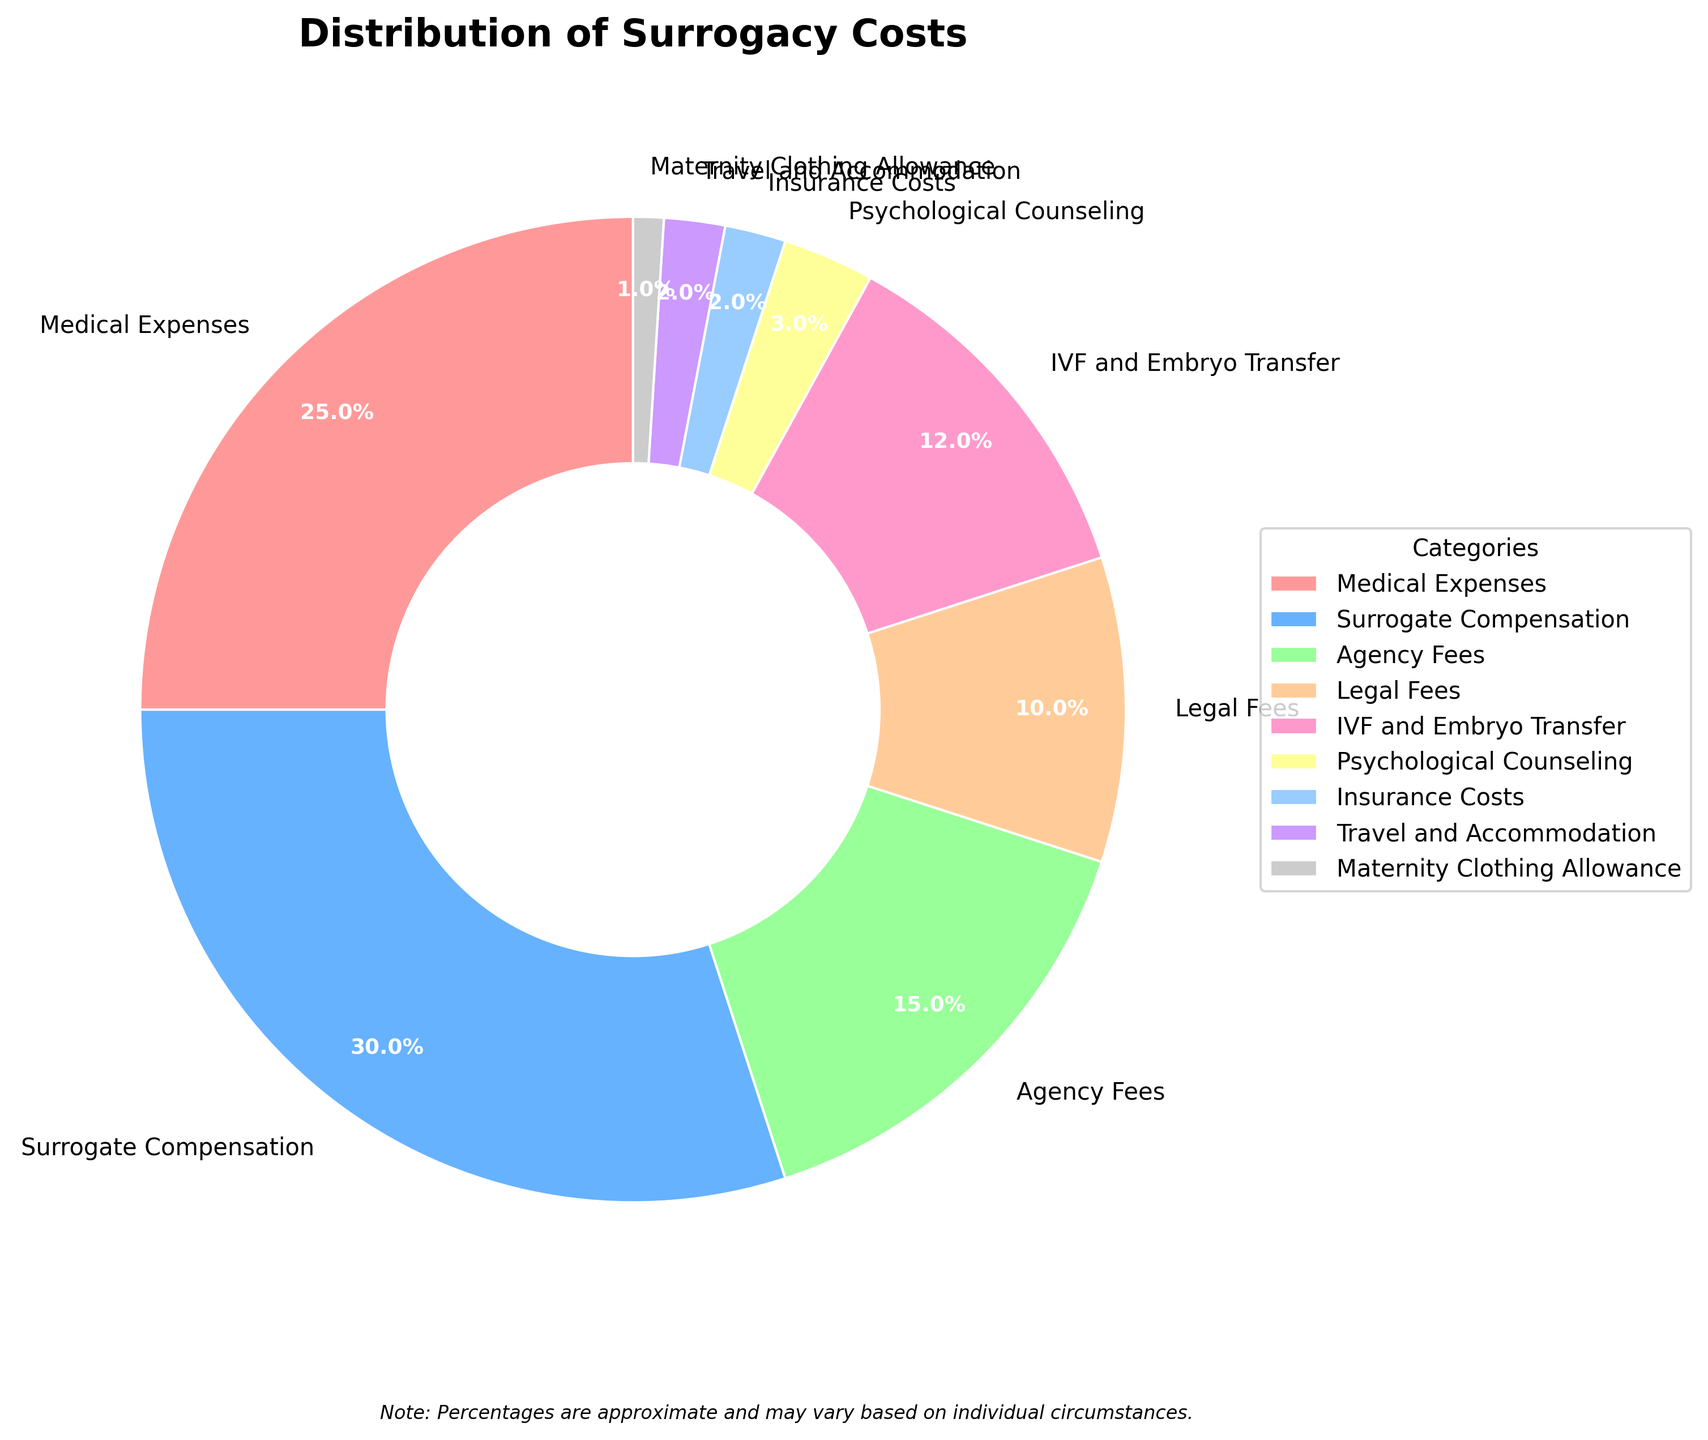What's the largest cost category for surrogacy? The largest slice in the pie chart represents Surrogate Compensation, which is 30%.
Answer: Surrogate Compensation What is the difference in percentage between Medical Expenses and Agency Fees? Medical Expenses represent 25%, while Agency Fees are 15%. The difference is 25% - 15% = 10%.
Answer: 10% What is the total percentage of costs represented by the combination of Psychological Counseling, Insurance Costs, Travel and Accommodation, and Maternity Clothing Allowance? Psychological Counseling is 3%, Insurance Costs are 2%, Travel and Accommodation is 2%, and Maternity Clothing Allowance is 1%. Summing these up: 3% + 2% + 2% + 1% = 8%.
Answer: 8% Which category costs more: IVF and Embryo Transfer or Legal Fees? IVF and Embryo Transfer account for 12%, while Legal Fees are 10%. IVF and Embryo Transfer is higher.
Answer: IVF and Embryo Transfer How much more does Surrogate Compensation cost compared to Legal Fees? Surrogate Compensation is 30%, while Legal Fees are 10%. The difference is 30% - 10% = 20%.
Answer: 20% Which cost categories collectively account for at least half of the surrogacy costs? Surrogate Compensation (30%), Medical Expenses (25%). Summing these gives 30% + 25% = 55%, which is more than half.
Answer: Surrogate Compensation and Medical Expenses What percentage of the costs are associated with both Medical Expenses and IVF and Embryo Transfer? Medical Expenses are 25% and IVF and Embryo Transfer is 12%. Summing these gives 25% + 12% = 37%.
Answer: 37% Compared to Agency Fees, how many more categories have costs less than Travel and Accommodation? Agency Fees are 15% and Travel and Accommodation is 2%. Categories with less than 2% are Insurance Costs (2%) and Maternity Clothing Allowance (1%). Hence, there is only 1 category (Maternity Clothing Allowance) with costs less than Travel and Accommodation.
Answer: 1 How much does the smallest category cost relative to the largest category? The smallest category is Maternity Clothing Allowance at 1% and the largest is Surrogate Compensation at 30%. The relative cost is 1% / 30% = 1/30 or approximately 3.33%.
Answer: 3.33% What is the combined percentage of Agency Fees, Legal Fees, and Psychological Counseling? Agency Fees are 15%, Legal Fees are 10%, and Psychological Counseling is 3%. Summing these up: 15% + 10% + 3% = 28%.
Answer: 28% 